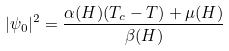<formula> <loc_0><loc_0><loc_500><loc_500>| \psi _ { 0 } | ^ { 2 } = \frac { \alpha ( H ) ( T _ { c } - T ) + \mu ( H ) } { \beta ( H ) }</formula> 